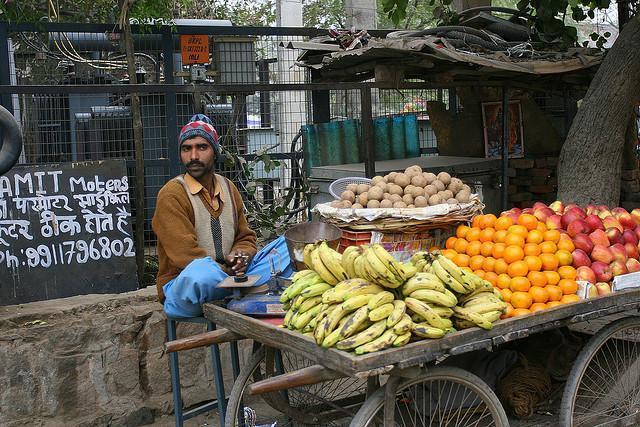How many types of fruit is this man selling?
Give a very brief answer. 4. How many bananas can you see?
Give a very brief answer. 2. 